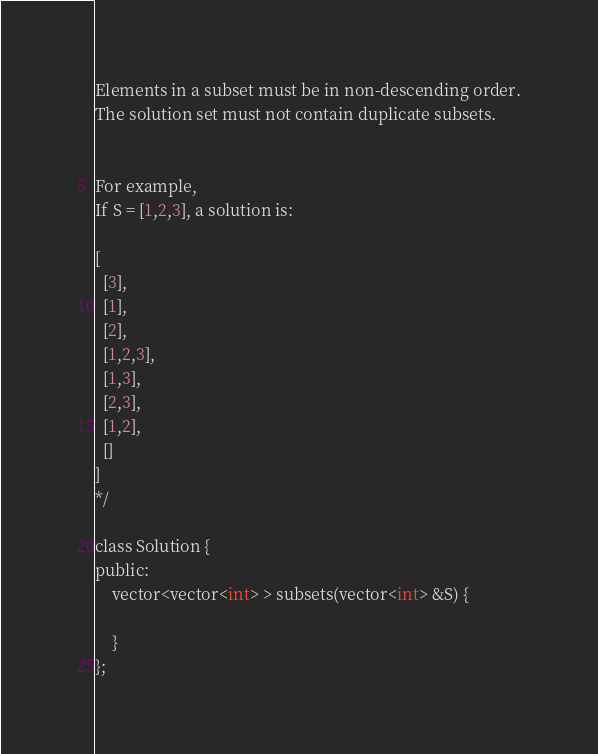<code> <loc_0><loc_0><loc_500><loc_500><_C_>Elements in a subset must be in non-descending order.
The solution set must not contain duplicate subsets.


For example,
If S = [1,2,3], a solution is:

[
  [3],
  [1],
  [2],
  [1,2,3],
  [1,3],
  [2,3],
  [1,2],
  []
]
*/

class Solution {
public:
    vector<vector<int> > subsets(vector<int> &S) {
        
    }
};</code> 